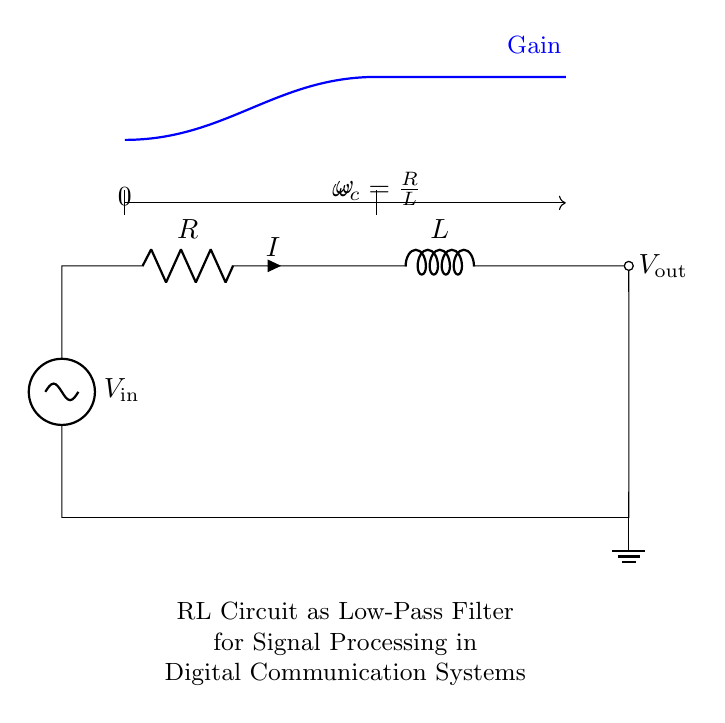What is the input voltage in this circuit? The input voltage is denoted as V in the circuit diagram, which is the voltage source connected at the leftmost side.
Answer: V in What is the output voltage denoted in the circuit? The output voltage is represented as V out, which is taken across the inductor and resistor in the circuit.
Answer: V out What components are present in the circuit? The circuit contains a voltage source, a resistor, and an inductor. These components are visually identifiable in the circuit diagram.
Answer: Voltage source, resistor, inductor What is the cutoff frequency of this low-pass filter? The cutoff frequency, denoted as omega_c, is calculated using the formula omega_c = R/L. It determines the frequency at which the output voltage falls to a certain fraction of the input voltage.
Answer: R over L How does the inductor affect the high-frequency signals in this circuit? The inductor opposes changes in current, and for high-frequency signals, it presents a higher impedance which attenuates those signals, allowing only lower frequencies to pass.
Answer: Attenuates What happens to the gain of the circuit as frequency increases? As frequency increases, the gain of the circuit decreases, illustrating that higher-frequency signals are filtered out by the RL circuit, adhering to its low-pass filter characteristics.
Answer: Decreases What is the role of the resistor in this RL circuit? The resistor limits the amount of current flowing through the circuit and contributes to setting the time constant for the filter response, impacting how quickly the circuit can respond to changes in input.
Answer: Current limiting 